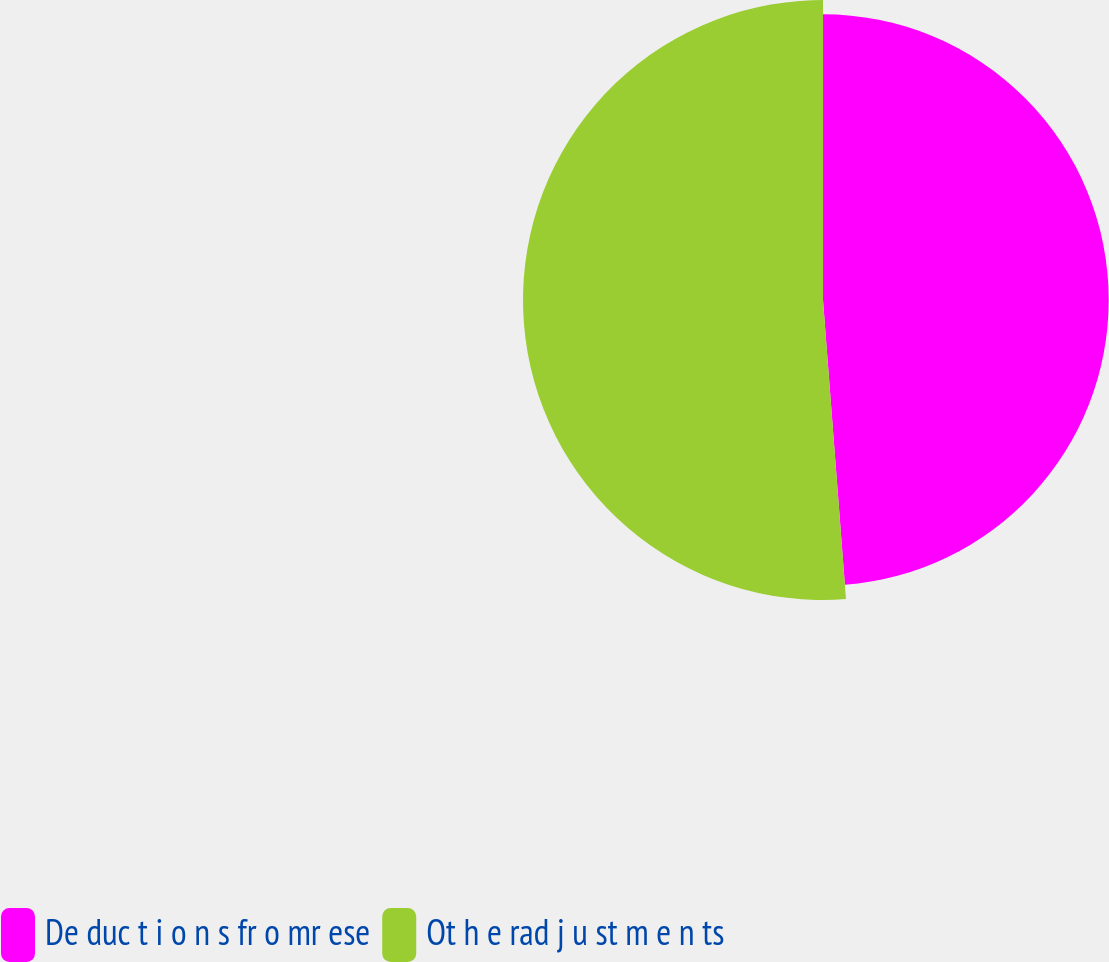Convert chart. <chart><loc_0><loc_0><loc_500><loc_500><pie_chart><fcel>De duc t i o n s fr o mr ese<fcel>Ot h e rad j u st m e n ts<nl><fcel>48.78%<fcel>51.22%<nl></chart> 